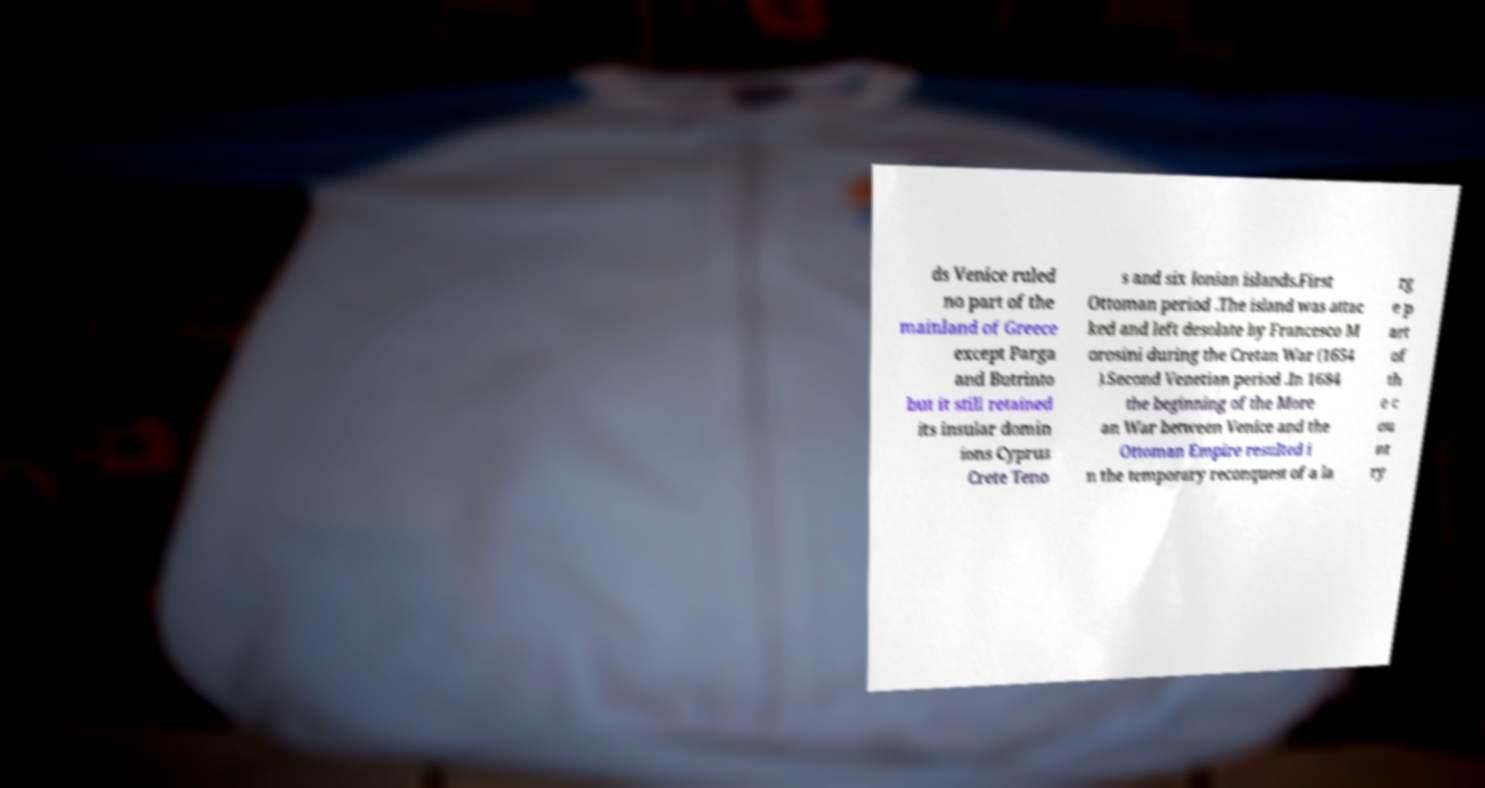Can you accurately transcribe the text from the provided image for me? ds Venice ruled no part of the mainland of Greece except Parga and Butrinto but it still retained its insular domin ions Cyprus Crete Teno s and six Ionian islands.First Ottoman period .The island was attac ked and left desolate by Francesco M orosini during the Cretan War (1654 ).Second Venetian period .In 1684 the beginning of the More an War between Venice and the Ottoman Empire resulted i n the temporary reconquest of a la rg e p art of th e c ou nt ry 